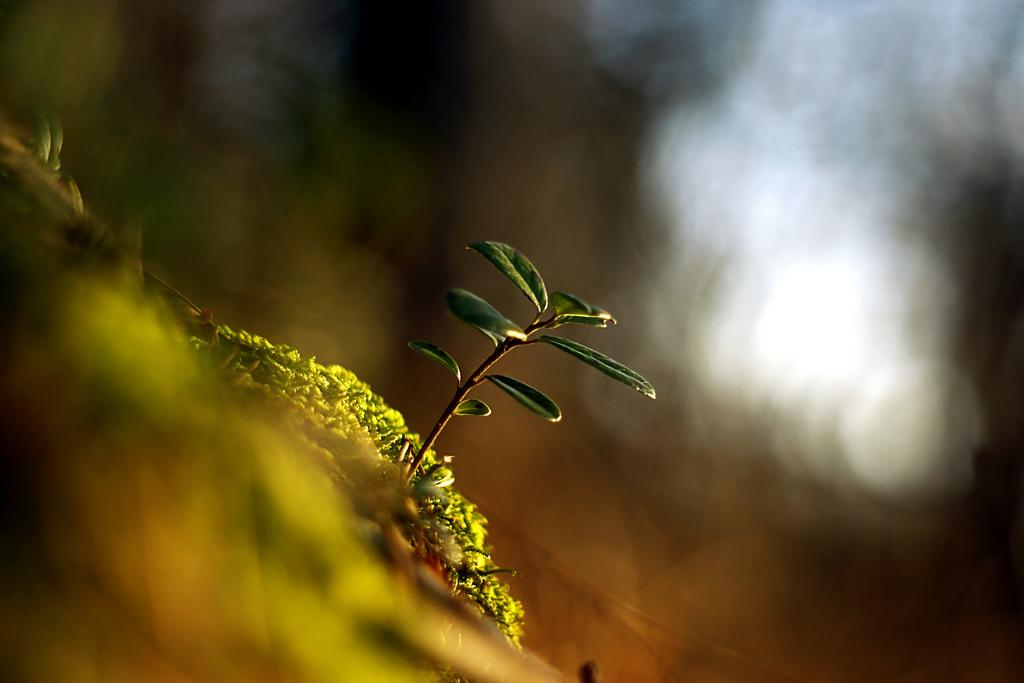What type of plant material can be seen in the image? There are leaves in the image. What part of the plant is visible in the image? There is a stem in the image. What type of rail system is present in the image? There is no rail system present in the image; it only features leaves and a stem. What organization is responsible for maintaining the plants in the image? There is no specific organization mentioned or implied in the image; it simply shows leaves and a stem. 